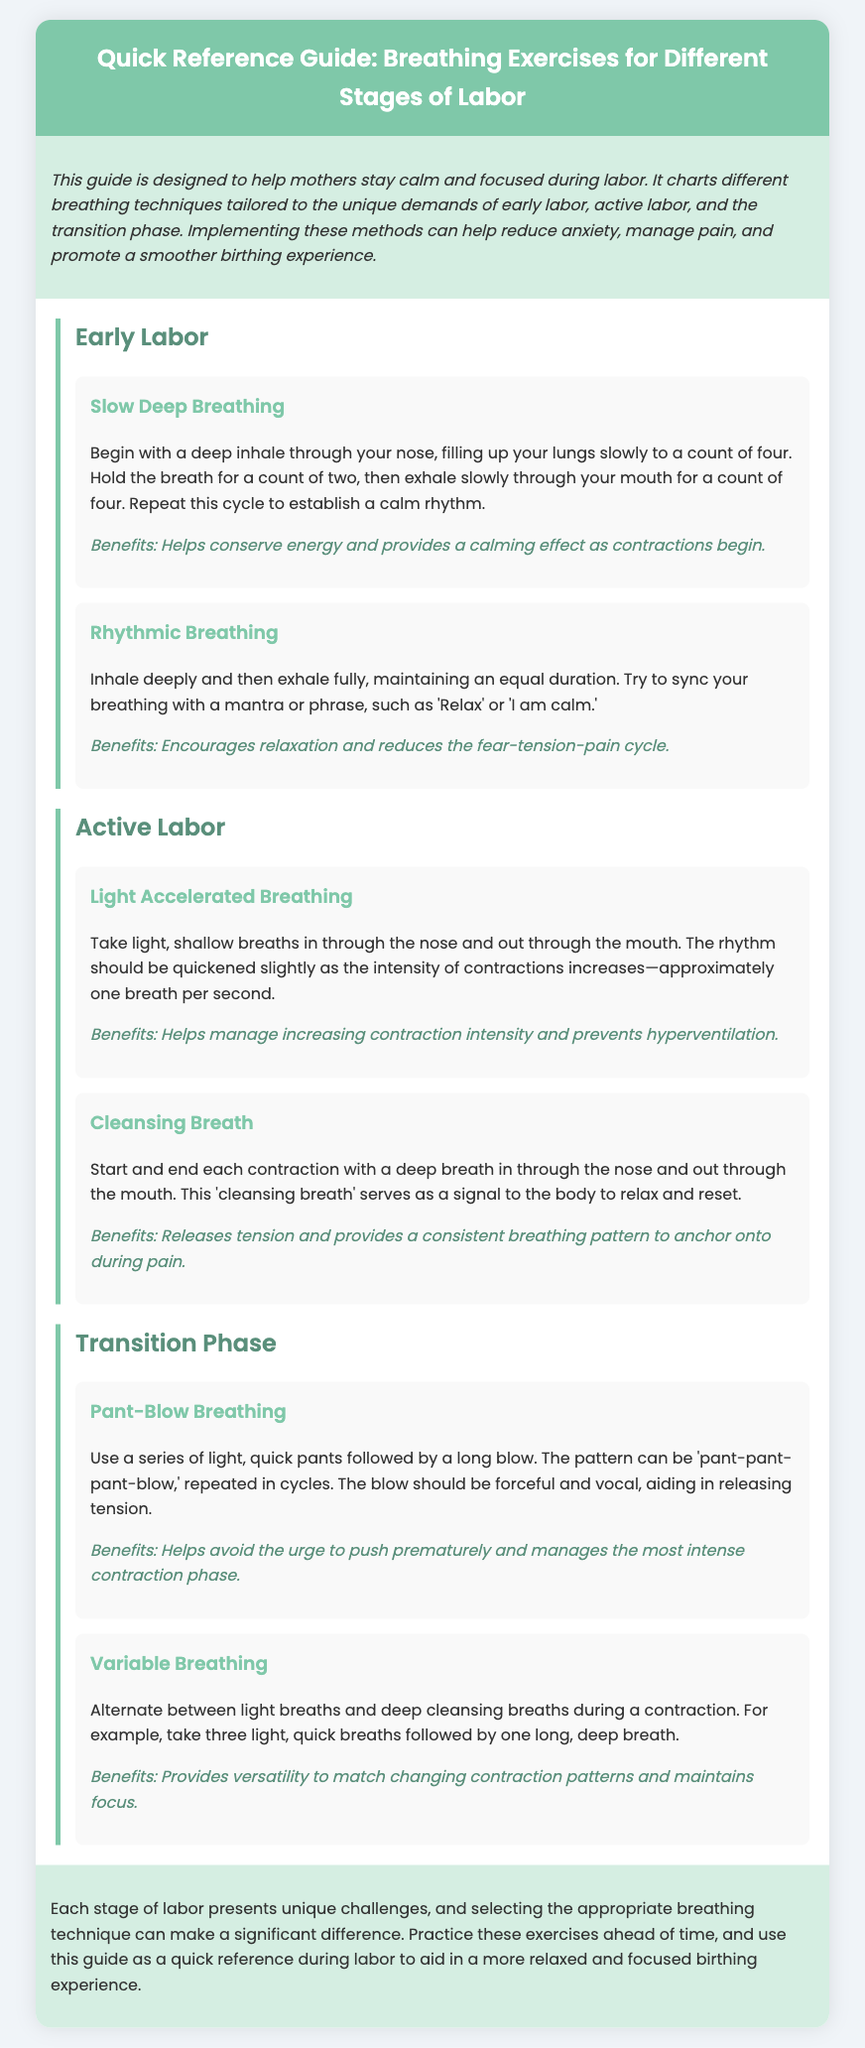What is the title of the guide? The title of the guide is explicitly stated at the top of the document in the header section.
Answer: Quick Reference Guide: Breathing Exercises for Different Stages of Labor How many breathing techniques are suggested for Early Labor? The document lists two specific breathing techniques for Early Labor within the designated section.
Answer: 2 What breathing technique involves "light, quick pants"? The document describes a technique specifically named after this action in the Transition Phase section.
Answer: Pant-Blow Breathing What is the main benefit of Slow Deep Breathing? The benefits of this technique are mentioned directly beneath its description, summarizing its calming effects.
Answer: Helps conserve energy and provides a calming effect Which breathing method starts and ends each contraction? The document identifies a specific breathing technique designed for this purpose in the Active Labor section.
Answer: Cleansing Breath What phase of labor features Variable Breathing? The phases of labor are clearly labeled in the document, specifying where this technique applies.
Answer: Transition Phase What color is used for the header background? The document's style includes a specific color code, which is used for the header's background.
Answer: #7fc8a9 How does the guide aim to help mothers during labor? The purpose of the guide is outlined in the introductory paragraph, highlighting its primary goal.
Answer: Stay calm and focused during labor 